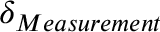<formula> <loc_0><loc_0><loc_500><loc_500>\delta _ { M e a s u r e m e n t }</formula> 